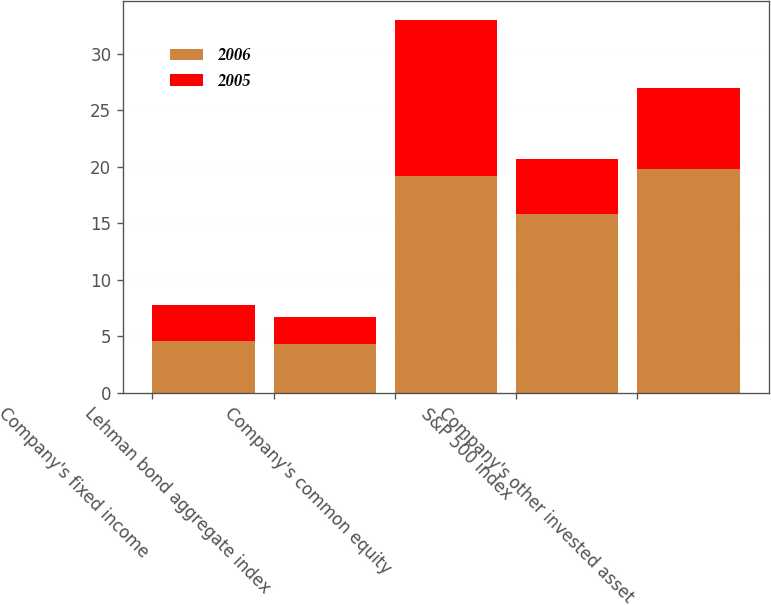Convert chart to OTSL. <chart><loc_0><loc_0><loc_500><loc_500><stacked_bar_chart><ecel><fcel>Company's fixed income<fcel>Lehman bond aggregate index<fcel>Company's common equity<fcel>S&P 500 index<fcel>Company's other invested asset<nl><fcel>2006<fcel>4.6<fcel>4.3<fcel>19.2<fcel>15.8<fcel>19.8<nl><fcel>2005<fcel>3.2<fcel>2.4<fcel>13.8<fcel>4.9<fcel>7.2<nl></chart> 